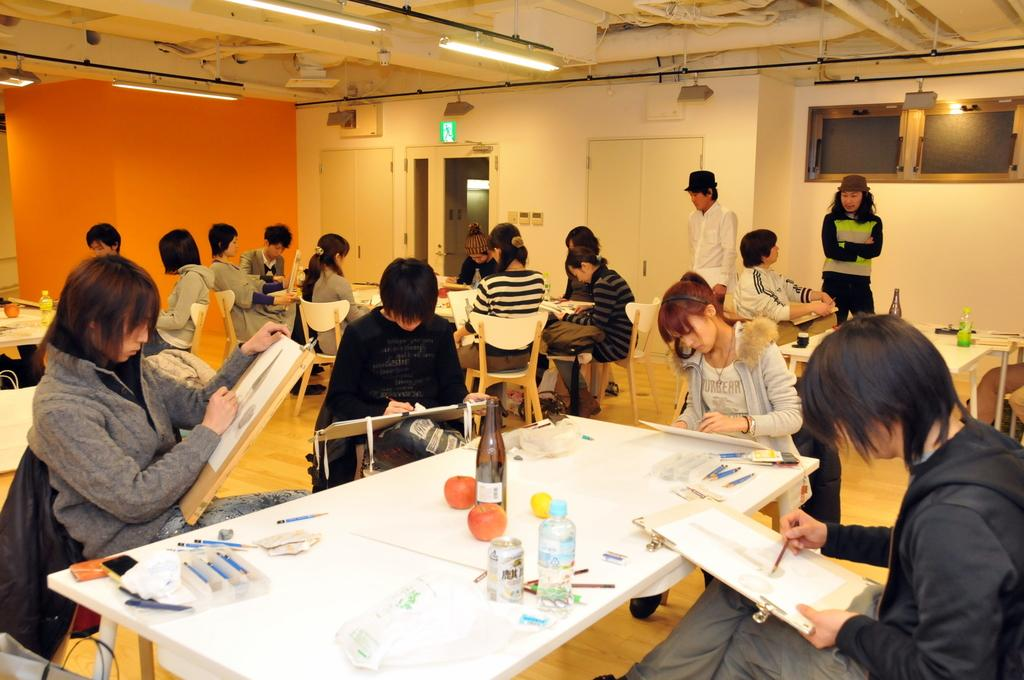How many people are in the image? There is a group of persons in the image. What are the persons in the image doing? The persons are sitting and painting. What objects can be seen at the foreground of the image? At the foreground of the image, there are bottles, paint brushes, and pens. What piece of furniture is present in the image? There is a table in the image. What type of spring can be seen in the image? There is no spring present in the image. How many cattle are visible in the image? There are no cattle present in the image. 